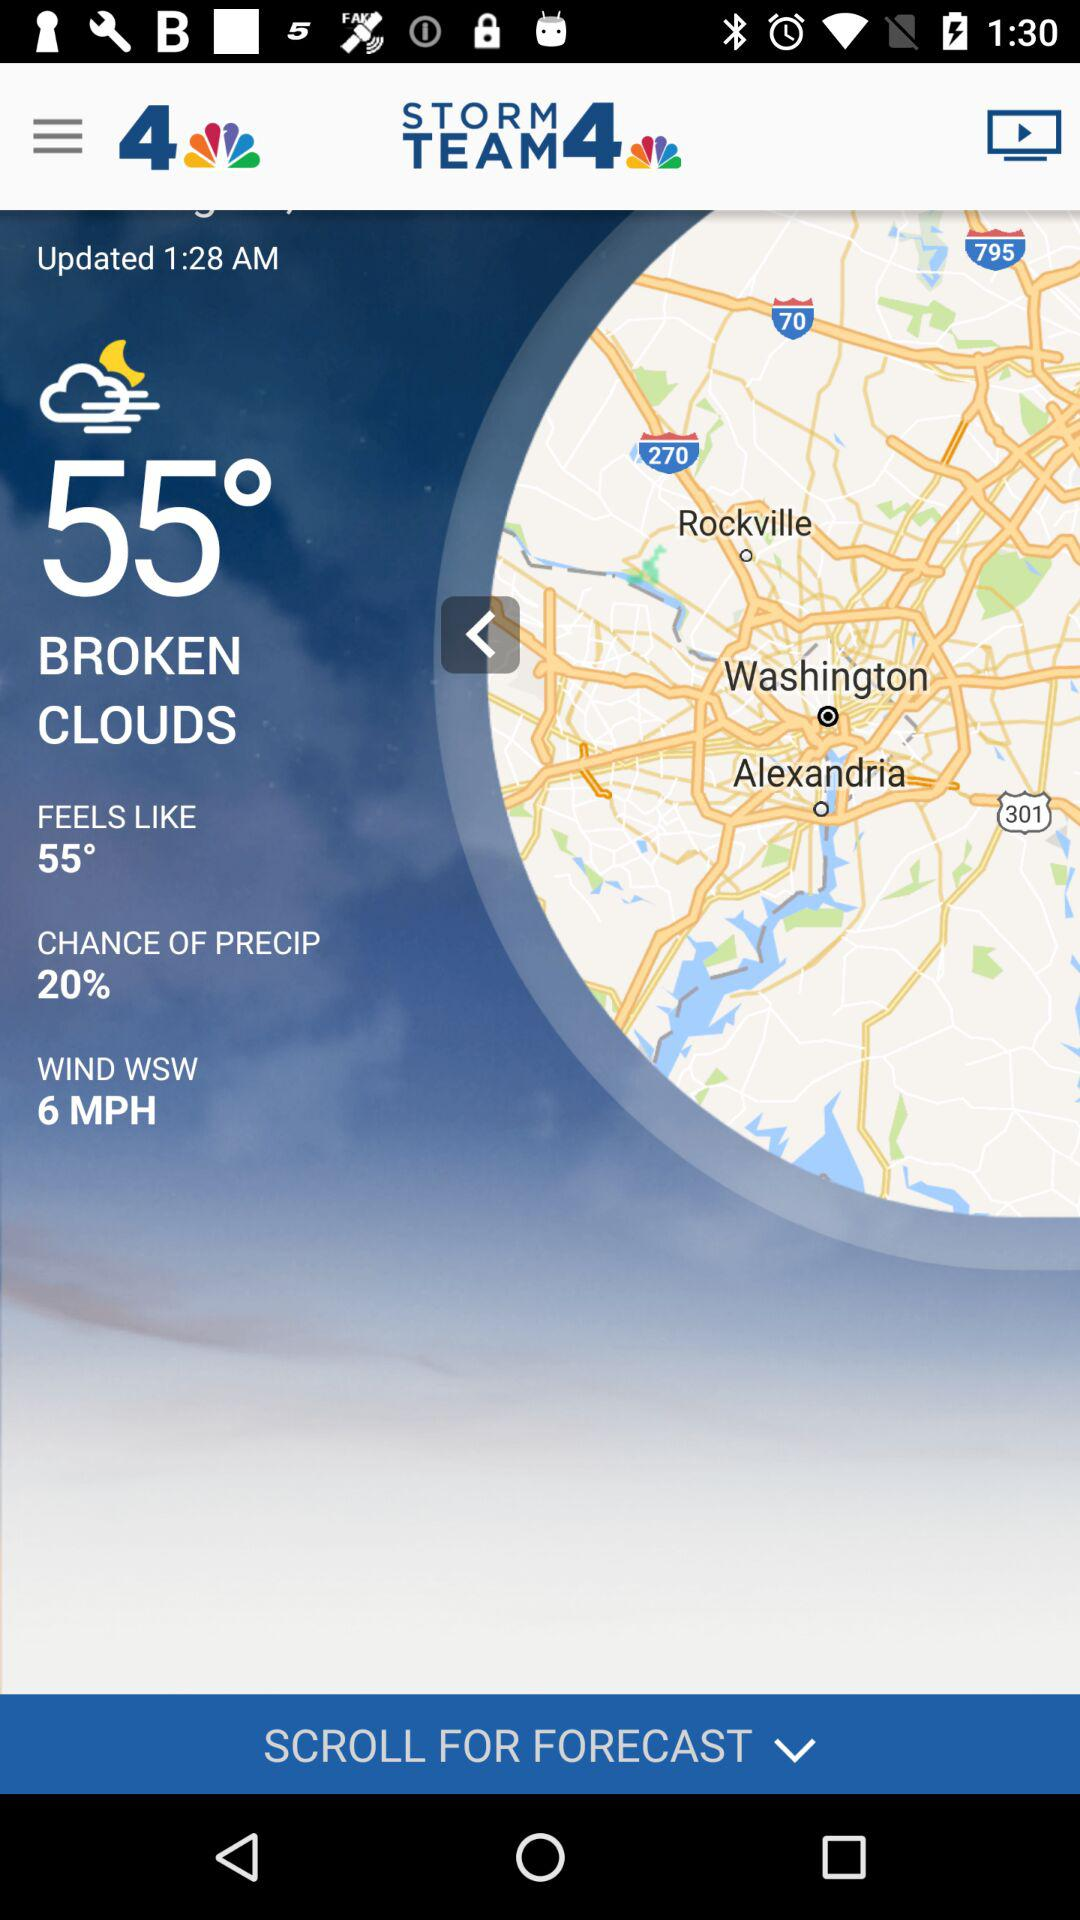How many more degrees fahrenheit is the current temperature than the feels like temperature?
Answer the question using a single word or phrase. 0 